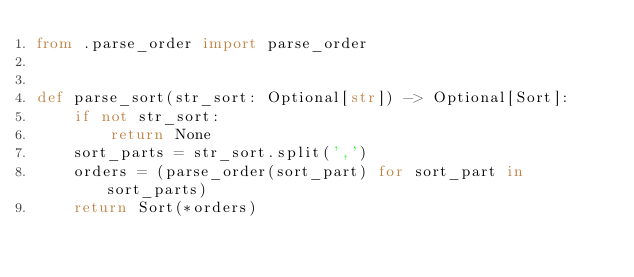Convert code to text. <code><loc_0><loc_0><loc_500><loc_500><_Python_>from .parse_order import parse_order


def parse_sort(str_sort: Optional[str]) -> Optional[Sort]:
    if not str_sort:
        return None
    sort_parts = str_sort.split(',')
    orders = (parse_order(sort_part) for sort_part in sort_parts)
    return Sort(*orders)
</code> 